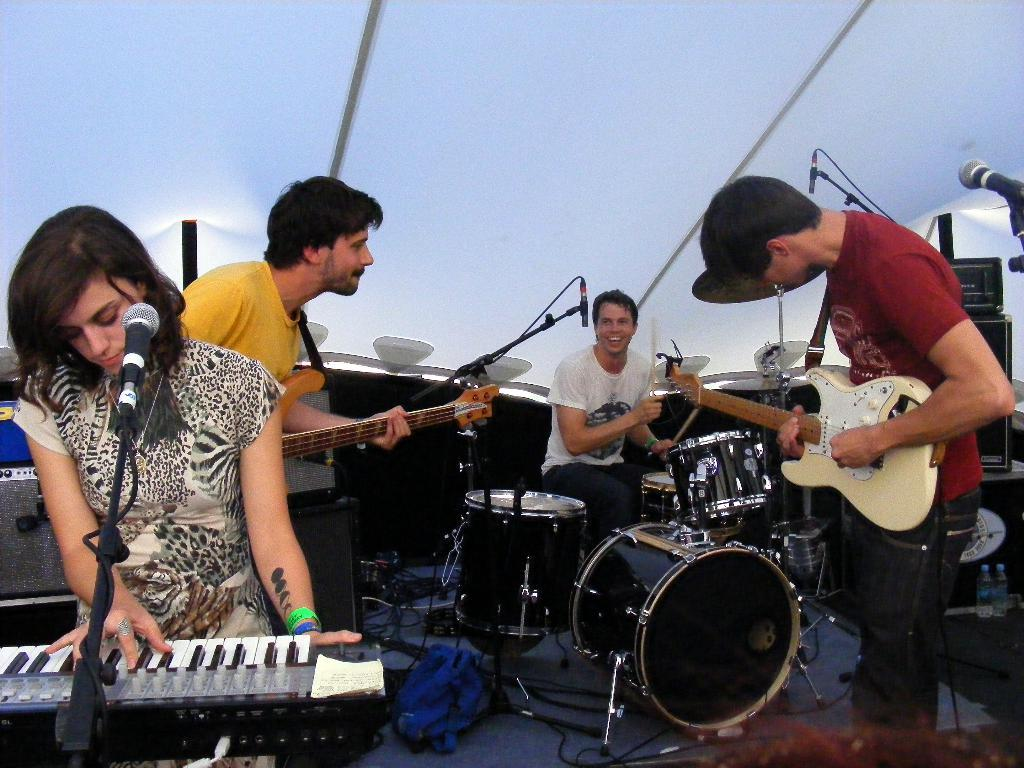What are the people in the image doing? The people in the image are playing musical instruments. Can you describe the specific instruments being played by the people? Two people are playing guitars, a guy is playing drums, and a lady is playing a piano. What type of soda is being served in the image? There is no soda present in the image; it features people playing musical instruments. How much noise is being generated by the people in the image? The amount of noise generated by the people playing musical instruments cannot be determined from the image alone. 